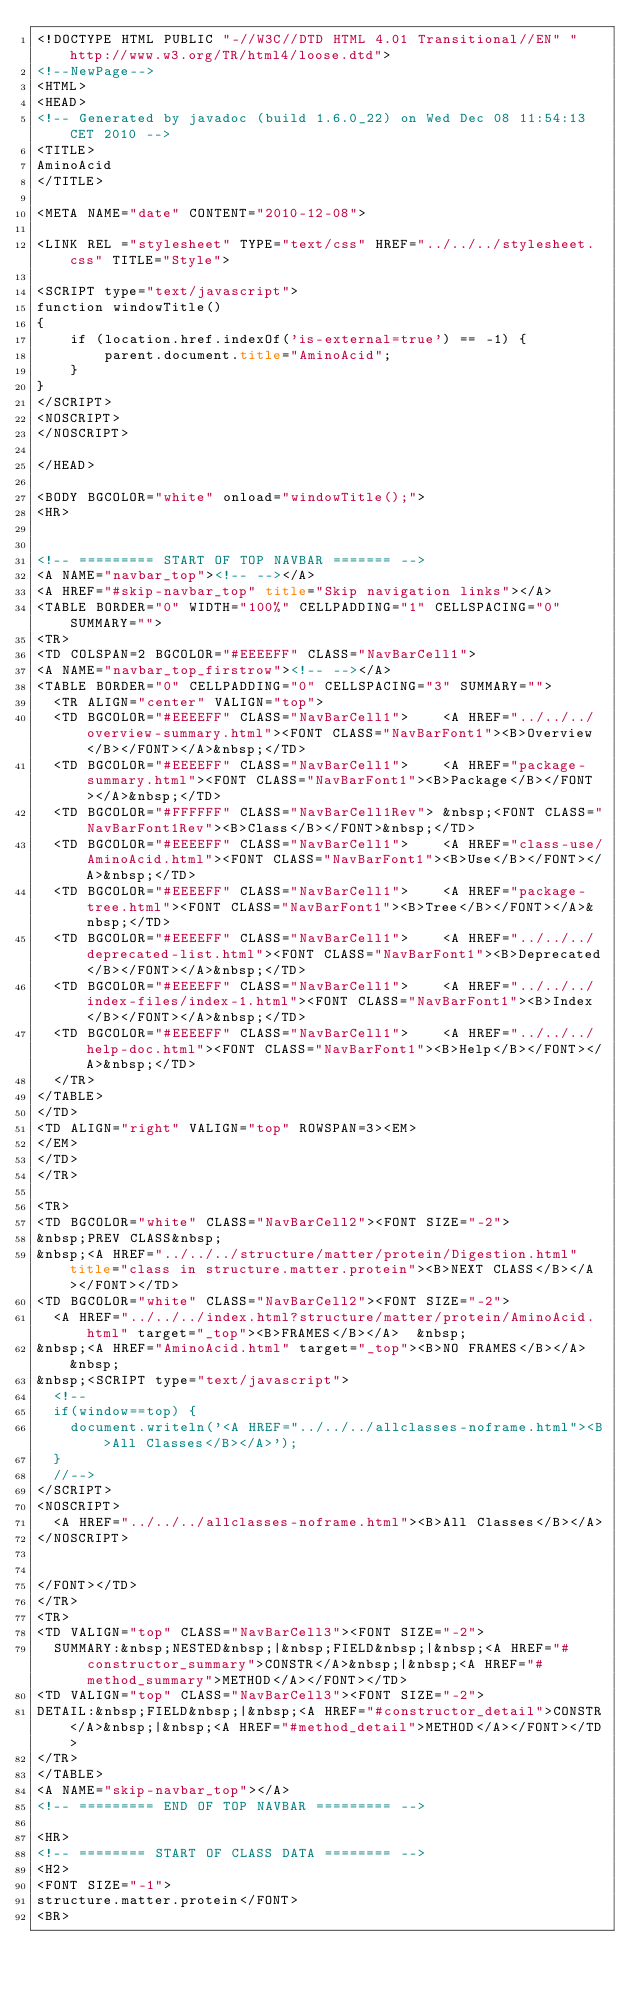Convert code to text. <code><loc_0><loc_0><loc_500><loc_500><_HTML_><!DOCTYPE HTML PUBLIC "-//W3C//DTD HTML 4.01 Transitional//EN" "http://www.w3.org/TR/html4/loose.dtd">
<!--NewPage-->
<HTML>
<HEAD>
<!-- Generated by javadoc (build 1.6.0_22) on Wed Dec 08 11:54:13 CET 2010 -->
<TITLE>
AminoAcid
</TITLE>

<META NAME="date" CONTENT="2010-12-08">

<LINK REL ="stylesheet" TYPE="text/css" HREF="../../../stylesheet.css" TITLE="Style">

<SCRIPT type="text/javascript">
function windowTitle()
{
    if (location.href.indexOf('is-external=true') == -1) {
        parent.document.title="AminoAcid";
    }
}
</SCRIPT>
<NOSCRIPT>
</NOSCRIPT>

</HEAD>

<BODY BGCOLOR="white" onload="windowTitle();">
<HR>


<!-- ========= START OF TOP NAVBAR ======= -->
<A NAME="navbar_top"><!-- --></A>
<A HREF="#skip-navbar_top" title="Skip navigation links"></A>
<TABLE BORDER="0" WIDTH="100%" CELLPADDING="1" CELLSPACING="0" SUMMARY="">
<TR>
<TD COLSPAN=2 BGCOLOR="#EEEEFF" CLASS="NavBarCell1">
<A NAME="navbar_top_firstrow"><!-- --></A>
<TABLE BORDER="0" CELLPADDING="0" CELLSPACING="3" SUMMARY="">
  <TR ALIGN="center" VALIGN="top">
  <TD BGCOLOR="#EEEEFF" CLASS="NavBarCell1">    <A HREF="../../../overview-summary.html"><FONT CLASS="NavBarFont1"><B>Overview</B></FONT></A>&nbsp;</TD>
  <TD BGCOLOR="#EEEEFF" CLASS="NavBarCell1">    <A HREF="package-summary.html"><FONT CLASS="NavBarFont1"><B>Package</B></FONT></A>&nbsp;</TD>
  <TD BGCOLOR="#FFFFFF" CLASS="NavBarCell1Rev"> &nbsp;<FONT CLASS="NavBarFont1Rev"><B>Class</B></FONT>&nbsp;</TD>
  <TD BGCOLOR="#EEEEFF" CLASS="NavBarCell1">    <A HREF="class-use/AminoAcid.html"><FONT CLASS="NavBarFont1"><B>Use</B></FONT></A>&nbsp;</TD>
  <TD BGCOLOR="#EEEEFF" CLASS="NavBarCell1">    <A HREF="package-tree.html"><FONT CLASS="NavBarFont1"><B>Tree</B></FONT></A>&nbsp;</TD>
  <TD BGCOLOR="#EEEEFF" CLASS="NavBarCell1">    <A HREF="../../../deprecated-list.html"><FONT CLASS="NavBarFont1"><B>Deprecated</B></FONT></A>&nbsp;</TD>
  <TD BGCOLOR="#EEEEFF" CLASS="NavBarCell1">    <A HREF="../../../index-files/index-1.html"><FONT CLASS="NavBarFont1"><B>Index</B></FONT></A>&nbsp;</TD>
  <TD BGCOLOR="#EEEEFF" CLASS="NavBarCell1">    <A HREF="../../../help-doc.html"><FONT CLASS="NavBarFont1"><B>Help</B></FONT></A>&nbsp;</TD>
  </TR>
</TABLE>
</TD>
<TD ALIGN="right" VALIGN="top" ROWSPAN=3><EM>
</EM>
</TD>
</TR>

<TR>
<TD BGCOLOR="white" CLASS="NavBarCell2"><FONT SIZE="-2">
&nbsp;PREV CLASS&nbsp;
&nbsp;<A HREF="../../../structure/matter/protein/Digestion.html" title="class in structure.matter.protein"><B>NEXT CLASS</B></A></FONT></TD>
<TD BGCOLOR="white" CLASS="NavBarCell2"><FONT SIZE="-2">
  <A HREF="../../../index.html?structure/matter/protein/AminoAcid.html" target="_top"><B>FRAMES</B></A>  &nbsp;
&nbsp;<A HREF="AminoAcid.html" target="_top"><B>NO FRAMES</B></A>  &nbsp;
&nbsp;<SCRIPT type="text/javascript">
  <!--
  if(window==top) {
    document.writeln('<A HREF="../../../allclasses-noframe.html"><B>All Classes</B></A>');
  }
  //-->
</SCRIPT>
<NOSCRIPT>
  <A HREF="../../../allclasses-noframe.html"><B>All Classes</B></A>
</NOSCRIPT>


</FONT></TD>
</TR>
<TR>
<TD VALIGN="top" CLASS="NavBarCell3"><FONT SIZE="-2">
  SUMMARY:&nbsp;NESTED&nbsp;|&nbsp;FIELD&nbsp;|&nbsp;<A HREF="#constructor_summary">CONSTR</A>&nbsp;|&nbsp;<A HREF="#method_summary">METHOD</A></FONT></TD>
<TD VALIGN="top" CLASS="NavBarCell3"><FONT SIZE="-2">
DETAIL:&nbsp;FIELD&nbsp;|&nbsp;<A HREF="#constructor_detail">CONSTR</A>&nbsp;|&nbsp;<A HREF="#method_detail">METHOD</A></FONT></TD>
</TR>
</TABLE>
<A NAME="skip-navbar_top"></A>
<!-- ========= END OF TOP NAVBAR ========= -->

<HR>
<!-- ======== START OF CLASS DATA ======== -->
<H2>
<FONT SIZE="-1">
structure.matter.protein</FONT>
<BR></code> 